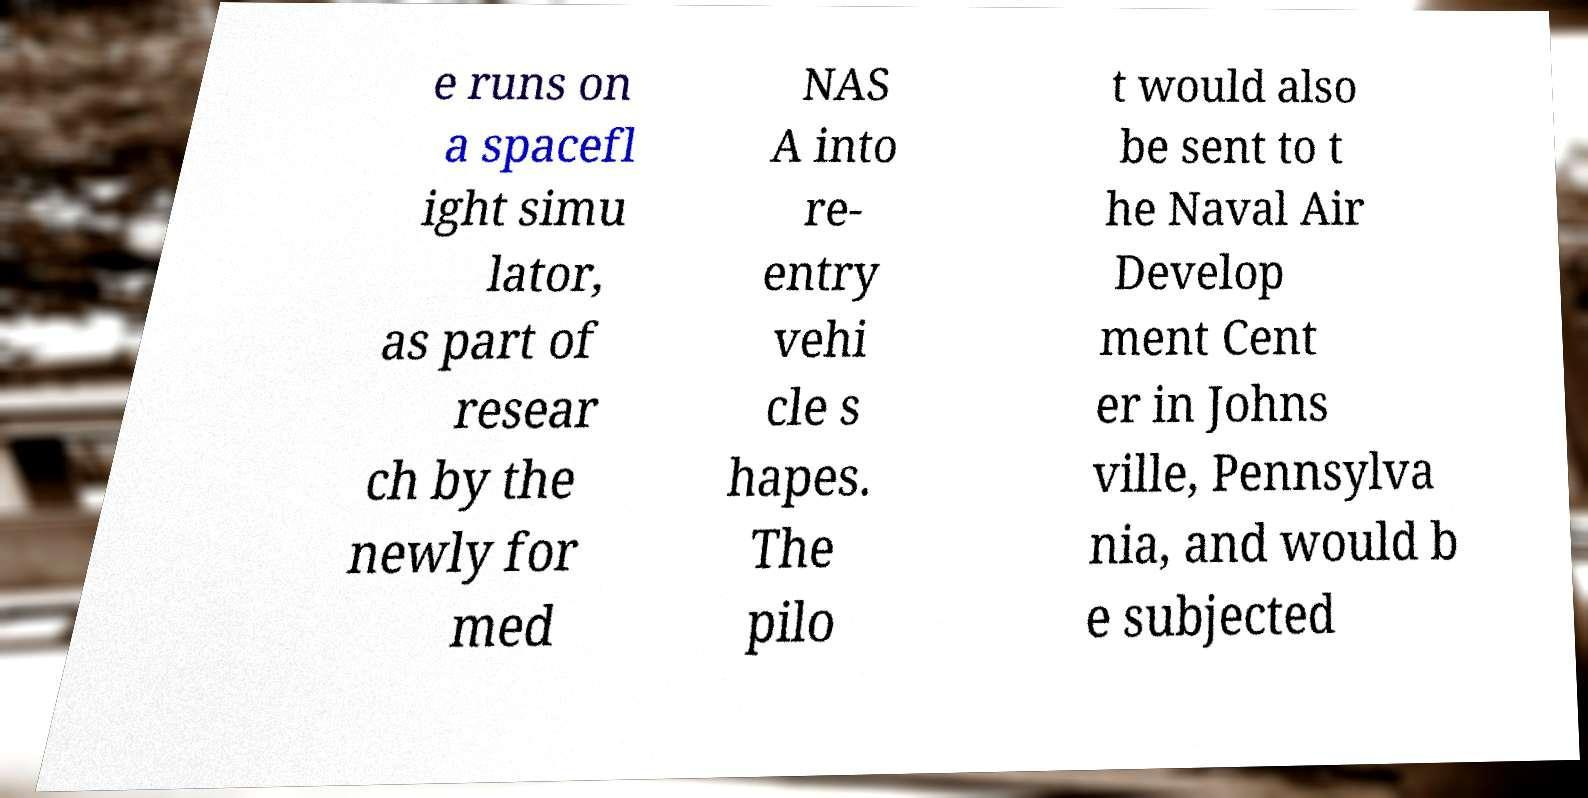There's text embedded in this image that I need extracted. Can you transcribe it verbatim? e runs on a spacefl ight simu lator, as part of resear ch by the newly for med NAS A into re- entry vehi cle s hapes. The pilo t would also be sent to t he Naval Air Develop ment Cent er in Johns ville, Pennsylva nia, and would b e subjected 